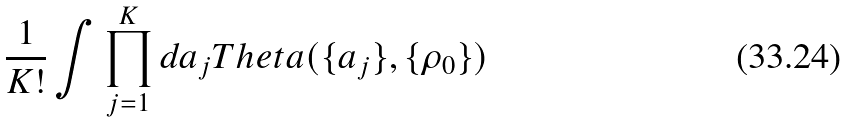<formula> <loc_0><loc_0><loc_500><loc_500>\frac { 1 } { K ! } \int \prod _ { j = 1 } ^ { K } d a _ { j } T h e t a ( \{ a _ { j } \} , \{ \rho _ { 0 } \} )</formula> 